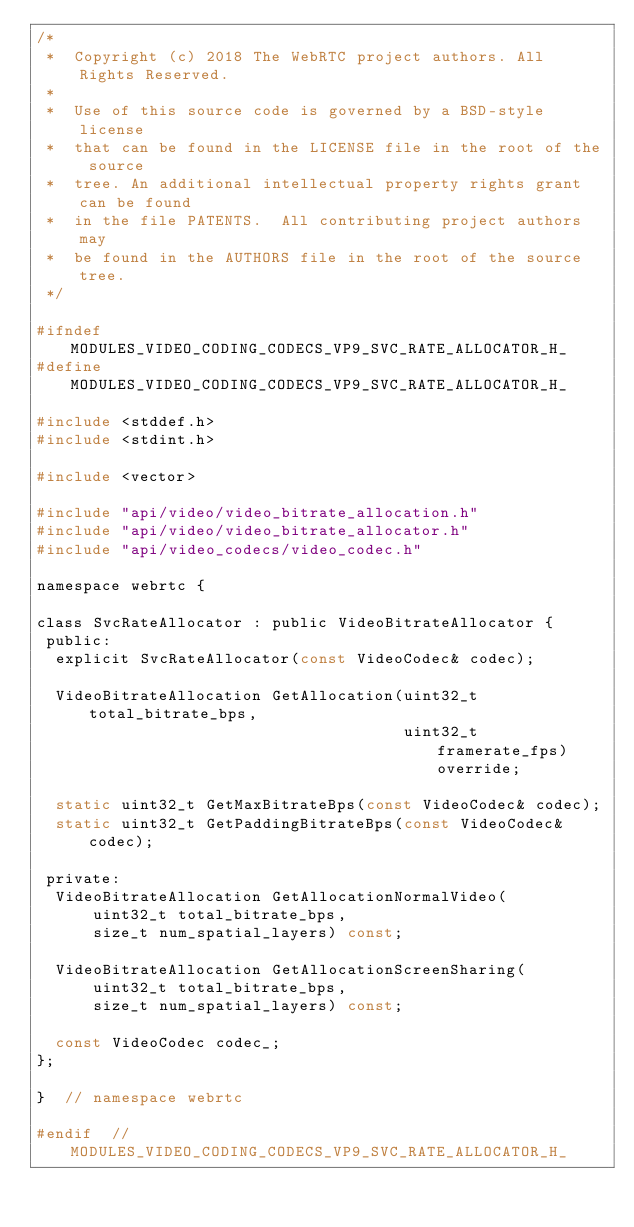<code> <loc_0><loc_0><loc_500><loc_500><_C_>/*
 *  Copyright (c) 2018 The WebRTC project authors. All Rights Reserved.
 *
 *  Use of this source code is governed by a BSD-style license
 *  that can be found in the LICENSE file in the root of the source
 *  tree. An additional intellectual property rights grant can be found
 *  in the file PATENTS.  All contributing project authors may
 *  be found in the AUTHORS file in the root of the source tree.
 */

#ifndef MODULES_VIDEO_CODING_CODECS_VP9_SVC_RATE_ALLOCATOR_H_
#define MODULES_VIDEO_CODING_CODECS_VP9_SVC_RATE_ALLOCATOR_H_

#include <stddef.h>
#include <stdint.h>

#include <vector>

#include "api/video/video_bitrate_allocation.h"
#include "api/video/video_bitrate_allocator.h"
#include "api/video_codecs/video_codec.h"

namespace webrtc {

class SvcRateAllocator : public VideoBitrateAllocator {
 public:
  explicit SvcRateAllocator(const VideoCodec& codec);

  VideoBitrateAllocation GetAllocation(uint32_t total_bitrate_bps,
                                       uint32_t framerate_fps) override;

  static uint32_t GetMaxBitrateBps(const VideoCodec& codec);
  static uint32_t GetPaddingBitrateBps(const VideoCodec& codec);

 private:
  VideoBitrateAllocation GetAllocationNormalVideo(
      uint32_t total_bitrate_bps,
      size_t num_spatial_layers) const;

  VideoBitrateAllocation GetAllocationScreenSharing(
      uint32_t total_bitrate_bps,
      size_t num_spatial_layers) const;

  const VideoCodec codec_;
};

}  // namespace webrtc

#endif  // MODULES_VIDEO_CODING_CODECS_VP9_SVC_RATE_ALLOCATOR_H_
</code> 